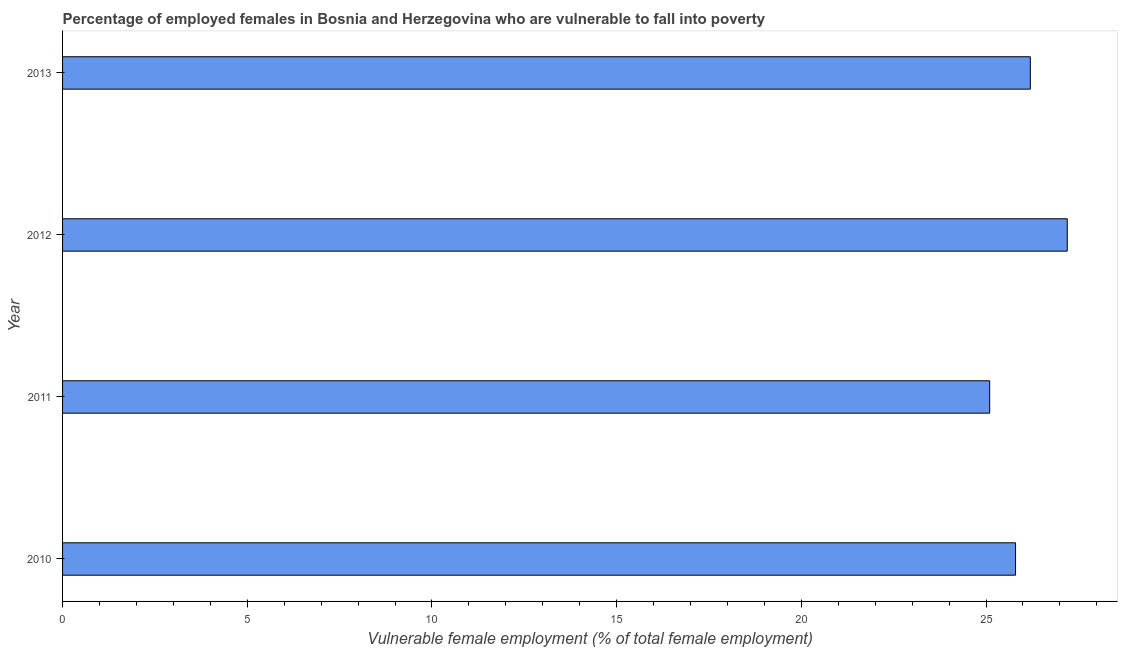Does the graph contain any zero values?
Your answer should be compact. No. What is the title of the graph?
Offer a terse response. Percentage of employed females in Bosnia and Herzegovina who are vulnerable to fall into poverty. What is the label or title of the X-axis?
Give a very brief answer. Vulnerable female employment (% of total female employment). What is the percentage of employed females who are vulnerable to fall into poverty in 2013?
Make the answer very short. 26.2. Across all years, what is the maximum percentage of employed females who are vulnerable to fall into poverty?
Your answer should be compact. 27.2. Across all years, what is the minimum percentage of employed females who are vulnerable to fall into poverty?
Provide a succinct answer. 25.1. What is the sum of the percentage of employed females who are vulnerable to fall into poverty?
Offer a terse response. 104.3. What is the average percentage of employed females who are vulnerable to fall into poverty per year?
Your response must be concise. 26.07. What is the median percentage of employed females who are vulnerable to fall into poverty?
Make the answer very short. 26. In how many years, is the percentage of employed females who are vulnerable to fall into poverty greater than 9 %?
Offer a very short reply. 4. What is the ratio of the percentage of employed females who are vulnerable to fall into poverty in 2010 to that in 2013?
Make the answer very short. 0.98. Is the percentage of employed females who are vulnerable to fall into poverty in 2012 less than that in 2013?
Ensure brevity in your answer.  No. What is the difference between the highest and the second highest percentage of employed females who are vulnerable to fall into poverty?
Keep it short and to the point. 1. Is the sum of the percentage of employed females who are vulnerable to fall into poverty in 2012 and 2013 greater than the maximum percentage of employed females who are vulnerable to fall into poverty across all years?
Your answer should be compact. Yes. What is the difference between the highest and the lowest percentage of employed females who are vulnerable to fall into poverty?
Offer a very short reply. 2.1. In how many years, is the percentage of employed females who are vulnerable to fall into poverty greater than the average percentage of employed females who are vulnerable to fall into poverty taken over all years?
Make the answer very short. 2. What is the difference between two consecutive major ticks on the X-axis?
Keep it short and to the point. 5. What is the Vulnerable female employment (% of total female employment) in 2010?
Offer a terse response. 25.8. What is the Vulnerable female employment (% of total female employment) in 2011?
Keep it short and to the point. 25.1. What is the Vulnerable female employment (% of total female employment) in 2012?
Keep it short and to the point. 27.2. What is the Vulnerable female employment (% of total female employment) of 2013?
Your answer should be very brief. 26.2. What is the difference between the Vulnerable female employment (% of total female employment) in 2010 and 2011?
Your answer should be compact. 0.7. What is the difference between the Vulnerable female employment (% of total female employment) in 2010 and 2012?
Make the answer very short. -1.4. What is the difference between the Vulnerable female employment (% of total female employment) in 2010 and 2013?
Your response must be concise. -0.4. What is the difference between the Vulnerable female employment (% of total female employment) in 2011 and 2012?
Provide a short and direct response. -2.1. What is the ratio of the Vulnerable female employment (% of total female employment) in 2010 to that in 2011?
Keep it short and to the point. 1.03. What is the ratio of the Vulnerable female employment (% of total female employment) in 2010 to that in 2012?
Provide a short and direct response. 0.95. What is the ratio of the Vulnerable female employment (% of total female employment) in 2010 to that in 2013?
Offer a terse response. 0.98. What is the ratio of the Vulnerable female employment (% of total female employment) in 2011 to that in 2012?
Offer a very short reply. 0.92. What is the ratio of the Vulnerable female employment (% of total female employment) in 2011 to that in 2013?
Your answer should be very brief. 0.96. What is the ratio of the Vulnerable female employment (% of total female employment) in 2012 to that in 2013?
Give a very brief answer. 1.04. 